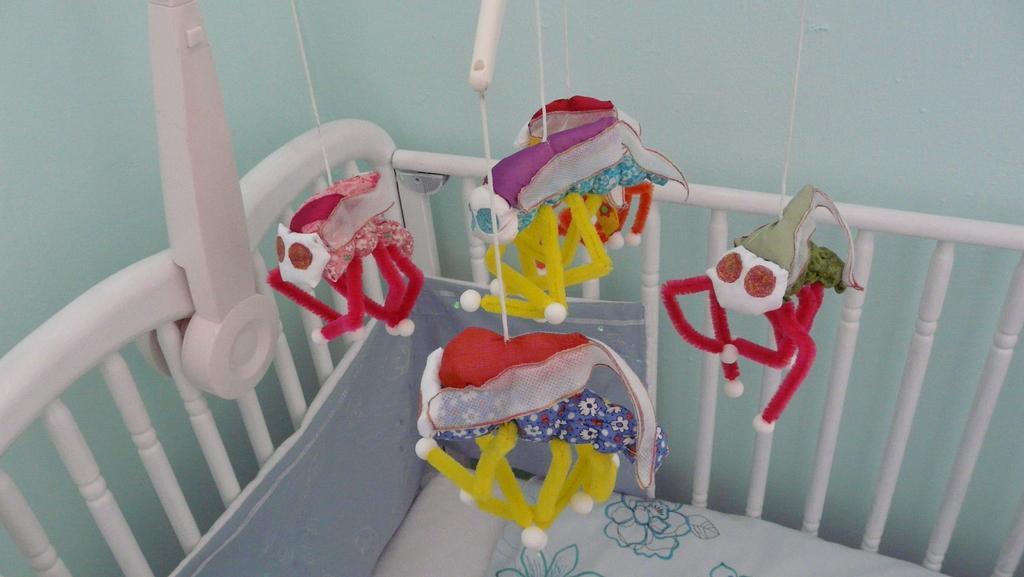How would you summarize this image in a sentence or two? In this image we can see some toys hanging and we can also see the cradle. 